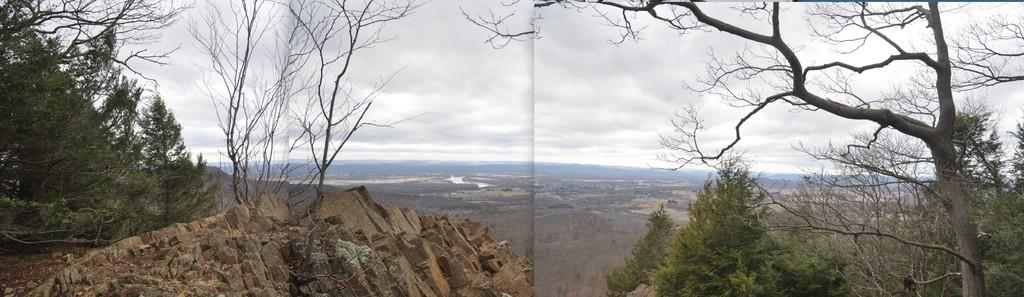What type of artwork is the image? The image is a collage. What natural elements can be seen in the collage? There are trees, rocks, and mountains in the image. What is visible in the background of the collage? The sky is visible in the background of the image. What atmospheric feature can be seen in the sky? Clouds are present in the sky. How does the basin contribute to the collage? There is no basin present in the collage. 